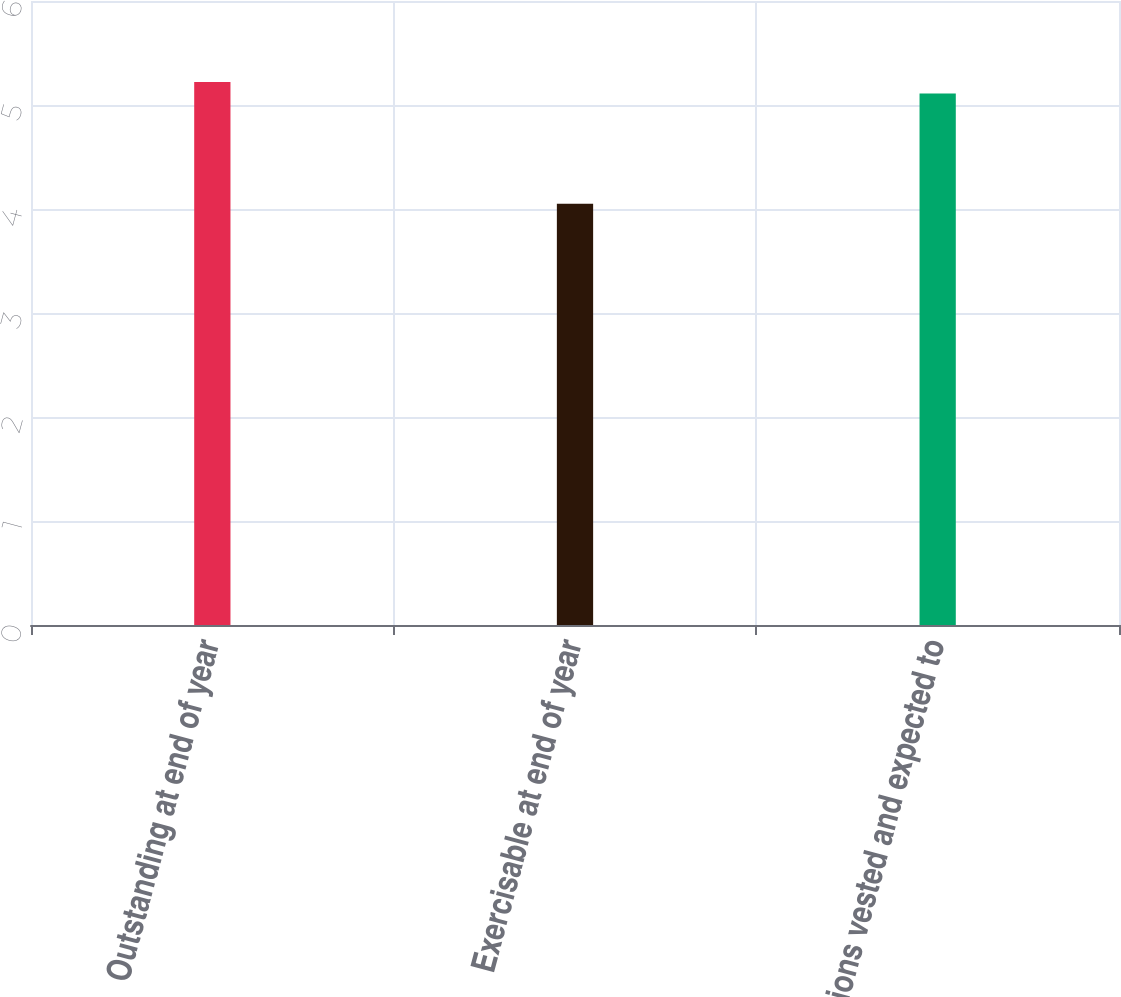<chart> <loc_0><loc_0><loc_500><loc_500><bar_chart><fcel>Outstanding at end of year<fcel>Exercisable at end of year<fcel>Options vested and expected to<nl><fcel>5.22<fcel>4.05<fcel>5.11<nl></chart> 